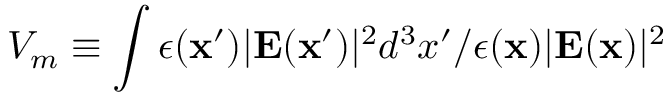Convert formula to latex. <formula><loc_0><loc_0><loc_500><loc_500>V _ { m } \equiv \int \epsilon ( { x } ^ { \prime } ) | E ( { x } ^ { \prime } ) | ^ { 2 } d ^ { 3 } x ^ { \prime } / \epsilon ( { x } ) | E ( { x } ) | ^ { 2 }</formula> 